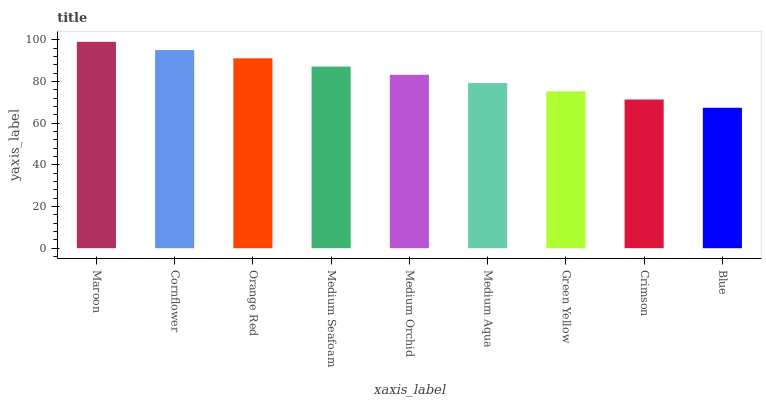Is Blue the minimum?
Answer yes or no. Yes. Is Maroon the maximum?
Answer yes or no. Yes. Is Cornflower the minimum?
Answer yes or no. No. Is Cornflower the maximum?
Answer yes or no. No. Is Maroon greater than Cornflower?
Answer yes or no. Yes. Is Cornflower less than Maroon?
Answer yes or no. Yes. Is Cornflower greater than Maroon?
Answer yes or no. No. Is Maroon less than Cornflower?
Answer yes or no. No. Is Medium Orchid the high median?
Answer yes or no. Yes. Is Medium Orchid the low median?
Answer yes or no. Yes. Is Cornflower the high median?
Answer yes or no. No. Is Cornflower the low median?
Answer yes or no. No. 